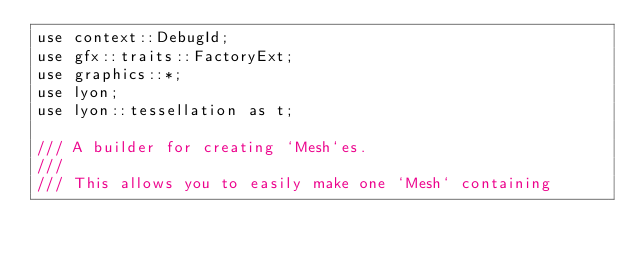<code> <loc_0><loc_0><loc_500><loc_500><_Rust_>use context::DebugId;
use gfx::traits::FactoryExt;
use graphics::*;
use lyon;
use lyon::tessellation as t;

/// A builder for creating `Mesh`es.
///
/// This allows you to easily make one `Mesh` containing</code> 